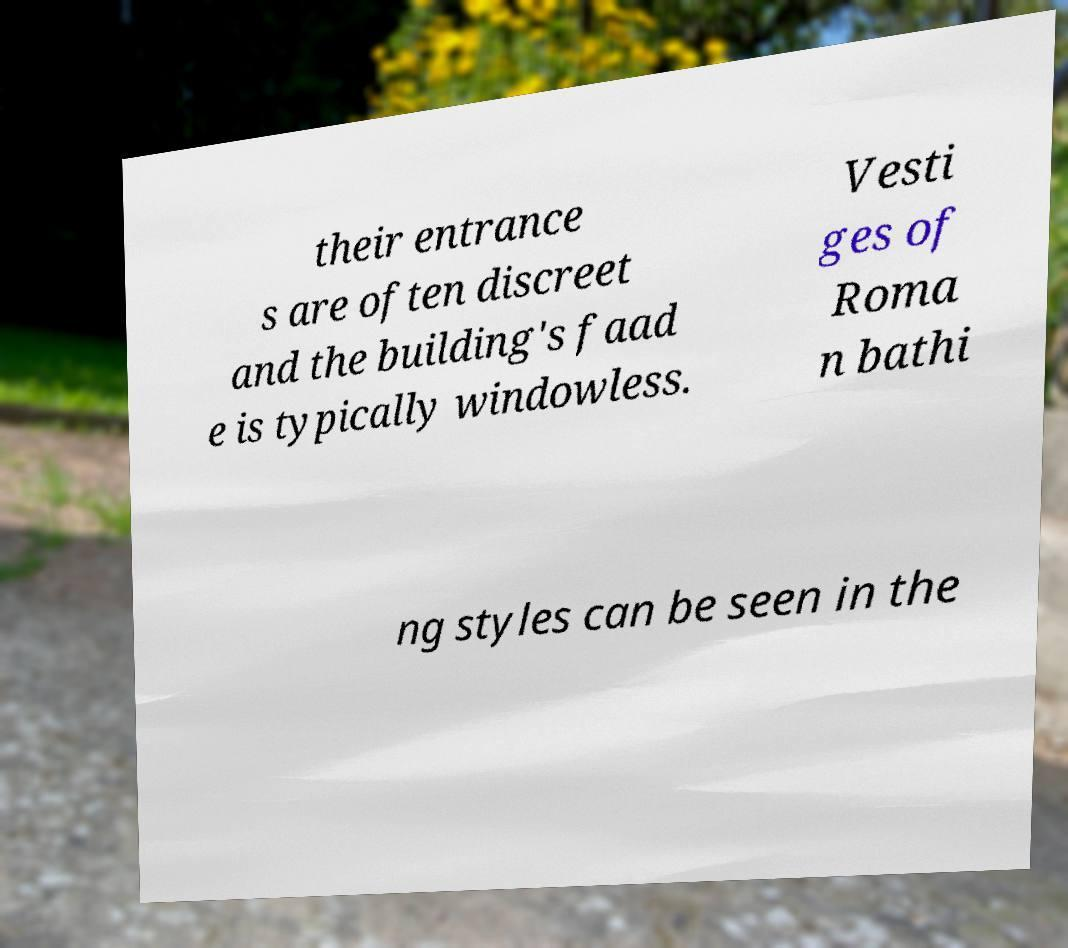For documentation purposes, I need the text within this image transcribed. Could you provide that? their entrance s are often discreet and the building's faad e is typically windowless. Vesti ges of Roma n bathi ng styles can be seen in the 